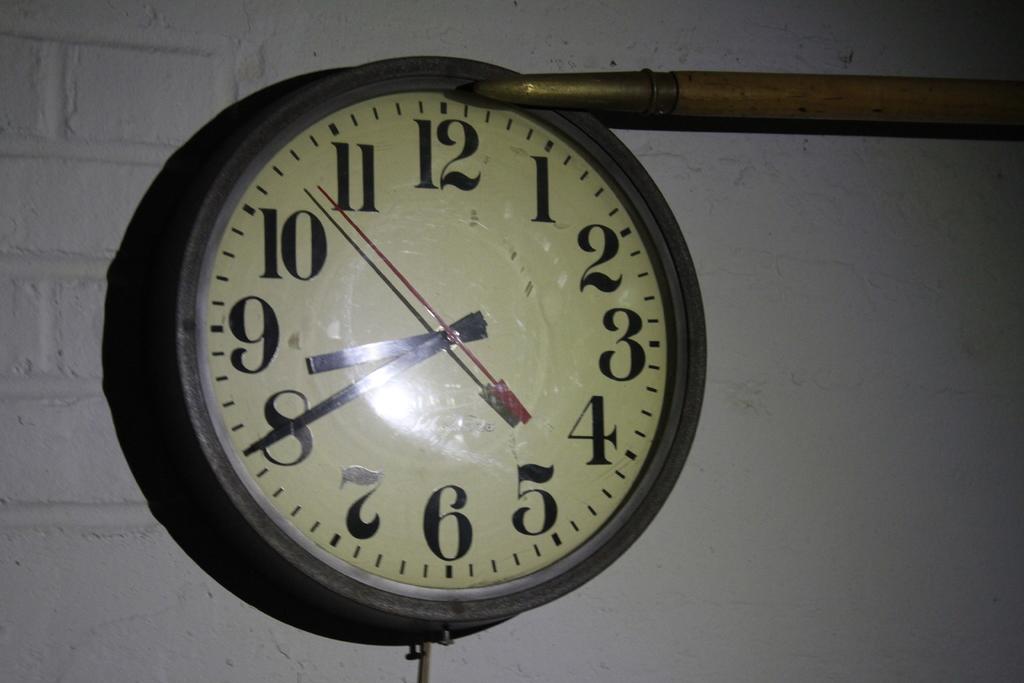What time is on the clock?
Give a very brief answer. 8:40. What number is closest to the longest hand of the clock?
Your answer should be very brief. 8. 